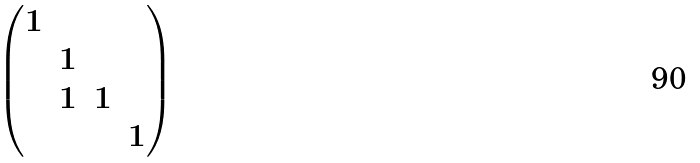Convert formula to latex. <formula><loc_0><loc_0><loc_500><loc_500>\begin{pmatrix} 1 & & & \\ & 1 & & \\ & 1 & 1 & \\ & & & 1 \end{pmatrix}</formula> 